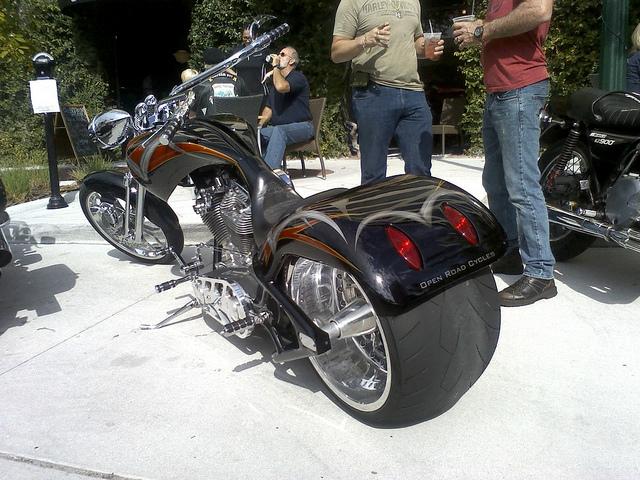Does the motorcycle have chrome parts?
Answer briefly. Yes. Is that a custom motorcycle?
Give a very brief answer. Yes. Are the people drinking alcohol?
Short answer required. Yes. 